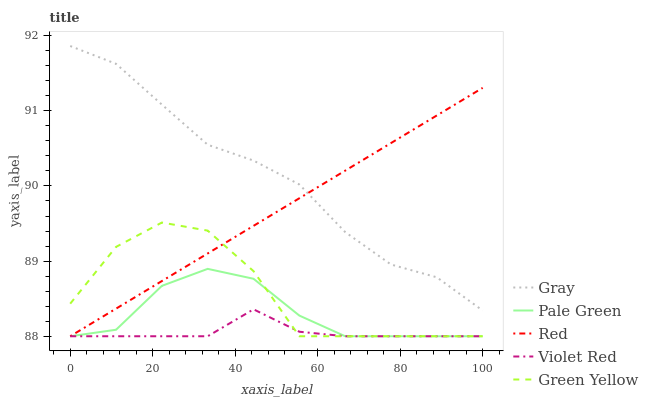Does Violet Red have the minimum area under the curve?
Answer yes or no. Yes. Does Gray have the maximum area under the curve?
Answer yes or no. Yes. Does Pale Green have the minimum area under the curve?
Answer yes or no. No. Does Pale Green have the maximum area under the curve?
Answer yes or no. No. Is Red the smoothest?
Answer yes or no. Yes. Is Green Yellow the roughest?
Answer yes or no. Yes. Is Violet Red the smoothest?
Answer yes or no. No. Is Violet Red the roughest?
Answer yes or no. No. Does Gray have the highest value?
Answer yes or no. Yes. Does Pale Green have the highest value?
Answer yes or no. No. Is Violet Red less than Gray?
Answer yes or no. Yes. Is Gray greater than Pale Green?
Answer yes or no. Yes. Does Violet Red intersect Pale Green?
Answer yes or no. Yes. Is Violet Red less than Pale Green?
Answer yes or no. No. Is Violet Red greater than Pale Green?
Answer yes or no. No. Does Violet Red intersect Gray?
Answer yes or no. No. 